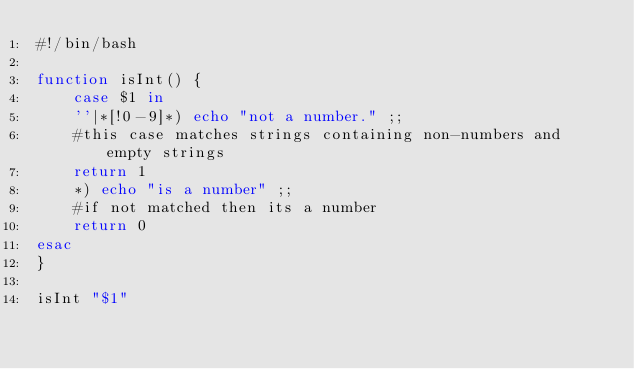<code> <loc_0><loc_0><loc_500><loc_500><_Bash_>#!/bin/bash

function isInt() {
    case $1 in
    ''|*[!0-9]*) echo "not a number." ;;
	#this case matches strings containing non-numbers and empty strings
	return 1
    *) echo "is a number" ;;
	#if not matched then its a number
	return 0
esac
}

isInt "$1"
</code> 